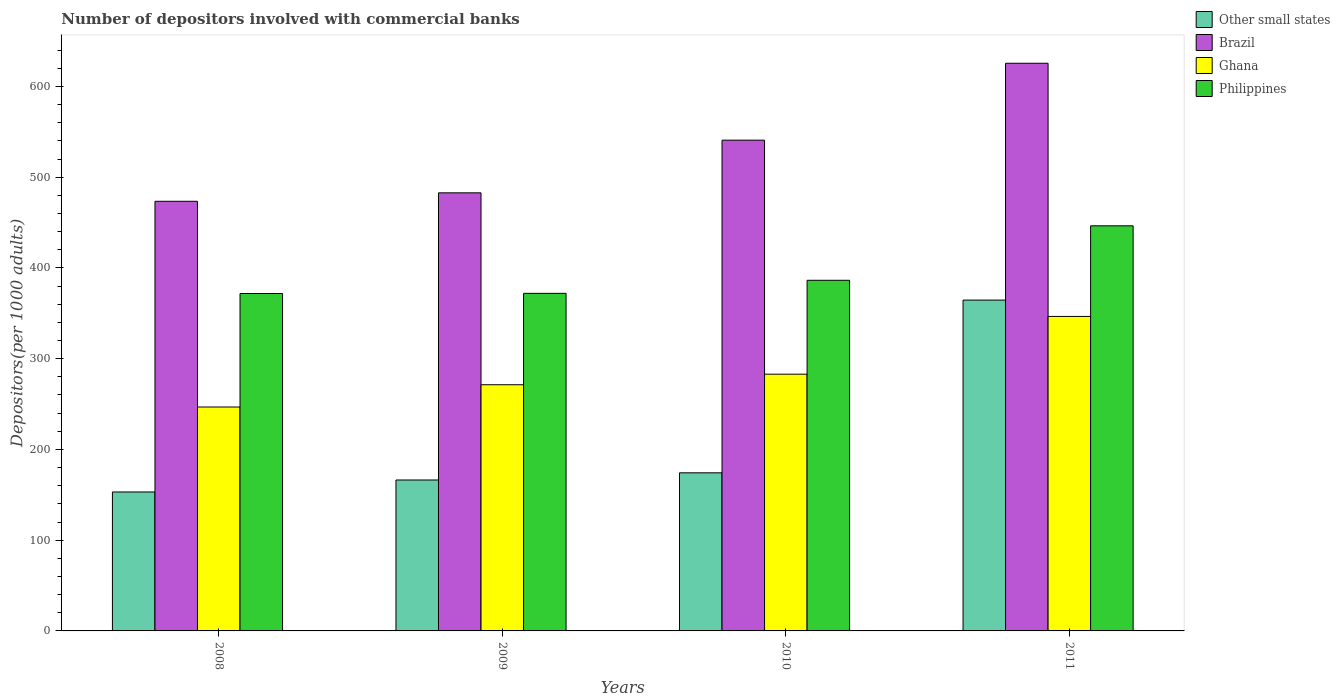How many different coloured bars are there?
Offer a very short reply. 4. How many groups of bars are there?
Your answer should be very brief. 4. Are the number of bars per tick equal to the number of legend labels?
Your answer should be compact. Yes. Are the number of bars on each tick of the X-axis equal?
Keep it short and to the point. Yes. How many bars are there on the 4th tick from the right?
Offer a very short reply. 4. What is the number of depositors involved with commercial banks in Brazil in 2009?
Your answer should be compact. 482.74. Across all years, what is the maximum number of depositors involved with commercial banks in Philippines?
Ensure brevity in your answer.  446.4. Across all years, what is the minimum number of depositors involved with commercial banks in Philippines?
Offer a very short reply. 371.81. In which year was the number of depositors involved with commercial banks in Ghana minimum?
Provide a short and direct response. 2008. What is the total number of depositors involved with commercial banks in Brazil in the graph?
Provide a short and direct response. 2122.49. What is the difference between the number of depositors involved with commercial banks in Ghana in 2008 and that in 2010?
Offer a very short reply. -36.17. What is the difference between the number of depositors involved with commercial banks in Other small states in 2010 and the number of depositors involved with commercial banks in Philippines in 2009?
Make the answer very short. -197.77. What is the average number of depositors involved with commercial banks in Ghana per year?
Your response must be concise. 286.87. In the year 2008, what is the difference between the number of depositors involved with commercial banks in Brazil and number of depositors involved with commercial banks in Ghana?
Offer a very short reply. 226.68. In how many years, is the number of depositors involved with commercial banks in Brazil greater than 100?
Your response must be concise. 4. What is the ratio of the number of depositors involved with commercial banks in Ghana in 2009 to that in 2011?
Offer a very short reply. 0.78. Is the difference between the number of depositors involved with commercial banks in Brazil in 2008 and 2009 greater than the difference between the number of depositors involved with commercial banks in Ghana in 2008 and 2009?
Offer a terse response. Yes. What is the difference between the highest and the second highest number of depositors involved with commercial banks in Other small states?
Offer a terse response. 190.35. What is the difference between the highest and the lowest number of depositors involved with commercial banks in Philippines?
Provide a short and direct response. 74.59. Is it the case that in every year, the sum of the number of depositors involved with commercial banks in Other small states and number of depositors involved with commercial banks in Ghana is greater than the sum of number of depositors involved with commercial banks in Philippines and number of depositors involved with commercial banks in Brazil?
Provide a succinct answer. No. What does the 4th bar from the right in 2009 represents?
Make the answer very short. Other small states. How many bars are there?
Your answer should be compact. 16. Are all the bars in the graph horizontal?
Make the answer very short. No. How many years are there in the graph?
Provide a short and direct response. 4. What is the difference between two consecutive major ticks on the Y-axis?
Your answer should be very brief. 100. Does the graph contain any zero values?
Offer a terse response. No. How many legend labels are there?
Your answer should be compact. 4. How are the legend labels stacked?
Offer a terse response. Vertical. What is the title of the graph?
Offer a terse response. Number of depositors involved with commercial banks. What is the label or title of the X-axis?
Offer a terse response. Years. What is the label or title of the Y-axis?
Offer a terse response. Depositors(per 1000 adults). What is the Depositors(per 1000 adults) of Other small states in 2008?
Keep it short and to the point. 153.11. What is the Depositors(per 1000 adults) of Brazil in 2008?
Make the answer very short. 473.42. What is the Depositors(per 1000 adults) in Ghana in 2008?
Make the answer very short. 246.75. What is the Depositors(per 1000 adults) in Philippines in 2008?
Provide a short and direct response. 371.81. What is the Depositors(per 1000 adults) of Other small states in 2009?
Your answer should be very brief. 166.31. What is the Depositors(per 1000 adults) of Brazil in 2009?
Give a very brief answer. 482.74. What is the Depositors(per 1000 adults) in Ghana in 2009?
Offer a terse response. 271.28. What is the Depositors(per 1000 adults) of Philippines in 2009?
Provide a short and direct response. 371.98. What is the Depositors(per 1000 adults) of Other small states in 2010?
Provide a short and direct response. 174.21. What is the Depositors(per 1000 adults) of Brazil in 2010?
Provide a short and direct response. 540.79. What is the Depositors(per 1000 adults) in Ghana in 2010?
Your answer should be very brief. 282.91. What is the Depositors(per 1000 adults) of Philippines in 2010?
Your answer should be compact. 386.38. What is the Depositors(per 1000 adults) of Other small states in 2011?
Your answer should be compact. 364.57. What is the Depositors(per 1000 adults) in Brazil in 2011?
Ensure brevity in your answer.  625.53. What is the Depositors(per 1000 adults) of Ghana in 2011?
Ensure brevity in your answer.  346.55. What is the Depositors(per 1000 adults) of Philippines in 2011?
Offer a very short reply. 446.4. Across all years, what is the maximum Depositors(per 1000 adults) in Other small states?
Give a very brief answer. 364.57. Across all years, what is the maximum Depositors(per 1000 adults) of Brazil?
Provide a succinct answer. 625.53. Across all years, what is the maximum Depositors(per 1000 adults) of Ghana?
Your response must be concise. 346.55. Across all years, what is the maximum Depositors(per 1000 adults) of Philippines?
Provide a succinct answer. 446.4. Across all years, what is the minimum Depositors(per 1000 adults) of Other small states?
Make the answer very short. 153.11. Across all years, what is the minimum Depositors(per 1000 adults) of Brazil?
Keep it short and to the point. 473.42. Across all years, what is the minimum Depositors(per 1000 adults) of Ghana?
Ensure brevity in your answer.  246.75. Across all years, what is the minimum Depositors(per 1000 adults) of Philippines?
Ensure brevity in your answer.  371.81. What is the total Depositors(per 1000 adults) of Other small states in the graph?
Provide a succinct answer. 858.19. What is the total Depositors(per 1000 adults) of Brazil in the graph?
Give a very brief answer. 2122.49. What is the total Depositors(per 1000 adults) of Ghana in the graph?
Make the answer very short. 1147.49. What is the total Depositors(per 1000 adults) in Philippines in the graph?
Offer a terse response. 1576.57. What is the difference between the Depositors(per 1000 adults) in Other small states in 2008 and that in 2009?
Give a very brief answer. -13.2. What is the difference between the Depositors(per 1000 adults) in Brazil in 2008 and that in 2009?
Keep it short and to the point. -9.32. What is the difference between the Depositors(per 1000 adults) in Ghana in 2008 and that in 2009?
Give a very brief answer. -24.54. What is the difference between the Depositors(per 1000 adults) in Philippines in 2008 and that in 2009?
Provide a short and direct response. -0.17. What is the difference between the Depositors(per 1000 adults) in Other small states in 2008 and that in 2010?
Provide a short and direct response. -21.11. What is the difference between the Depositors(per 1000 adults) of Brazil in 2008 and that in 2010?
Ensure brevity in your answer.  -67.37. What is the difference between the Depositors(per 1000 adults) in Ghana in 2008 and that in 2010?
Make the answer very short. -36.17. What is the difference between the Depositors(per 1000 adults) of Philippines in 2008 and that in 2010?
Make the answer very short. -14.57. What is the difference between the Depositors(per 1000 adults) of Other small states in 2008 and that in 2011?
Provide a short and direct response. -211.46. What is the difference between the Depositors(per 1000 adults) of Brazil in 2008 and that in 2011?
Your response must be concise. -152.11. What is the difference between the Depositors(per 1000 adults) of Ghana in 2008 and that in 2011?
Your answer should be very brief. -99.8. What is the difference between the Depositors(per 1000 adults) of Philippines in 2008 and that in 2011?
Your answer should be very brief. -74.59. What is the difference between the Depositors(per 1000 adults) of Other small states in 2009 and that in 2010?
Provide a short and direct response. -7.91. What is the difference between the Depositors(per 1000 adults) in Brazil in 2009 and that in 2010?
Provide a short and direct response. -58.05. What is the difference between the Depositors(per 1000 adults) of Ghana in 2009 and that in 2010?
Give a very brief answer. -11.63. What is the difference between the Depositors(per 1000 adults) in Philippines in 2009 and that in 2010?
Give a very brief answer. -14.4. What is the difference between the Depositors(per 1000 adults) in Other small states in 2009 and that in 2011?
Provide a short and direct response. -198.26. What is the difference between the Depositors(per 1000 adults) in Brazil in 2009 and that in 2011?
Give a very brief answer. -142.79. What is the difference between the Depositors(per 1000 adults) of Ghana in 2009 and that in 2011?
Your answer should be very brief. -75.26. What is the difference between the Depositors(per 1000 adults) in Philippines in 2009 and that in 2011?
Ensure brevity in your answer.  -74.42. What is the difference between the Depositors(per 1000 adults) in Other small states in 2010 and that in 2011?
Give a very brief answer. -190.35. What is the difference between the Depositors(per 1000 adults) of Brazil in 2010 and that in 2011?
Your answer should be very brief. -84.74. What is the difference between the Depositors(per 1000 adults) in Ghana in 2010 and that in 2011?
Ensure brevity in your answer.  -63.63. What is the difference between the Depositors(per 1000 adults) of Philippines in 2010 and that in 2011?
Provide a succinct answer. -60.02. What is the difference between the Depositors(per 1000 adults) in Other small states in 2008 and the Depositors(per 1000 adults) in Brazil in 2009?
Provide a short and direct response. -329.63. What is the difference between the Depositors(per 1000 adults) of Other small states in 2008 and the Depositors(per 1000 adults) of Ghana in 2009?
Ensure brevity in your answer.  -118.18. What is the difference between the Depositors(per 1000 adults) of Other small states in 2008 and the Depositors(per 1000 adults) of Philippines in 2009?
Your answer should be very brief. -218.87. What is the difference between the Depositors(per 1000 adults) in Brazil in 2008 and the Depositors(per 1000 adults) in Ghana in 2009?
Your response must be concise. 202.14. What is the difference between the Depositors(per 1000 adults) in Brazil in 2008 and the Depositors(per 1000 adults) in Philippines in 2009?
Your answer should be very brief. 101.44. What is the difference between the Depositors(per 1000 adults) of Ghana in 2008 and the Depositors(per 1000 adults) of Philippines in 2009?
Your response must be concise. -125.23. What is the difference between the Depositors(per 1000 adults) of Other small states in 2008 and the Depositors(per 1000 adults) of Brazil in 2010?
Your answer should be very brief. -387.69. What is the difference between the Depositors(per 1000 adults) in Other small states in 2008 and the Depositors(per 1000 adults) in Ghana in 2010?
Ensure brevity in your answer.  -129.81. What is the difference between the Depositors(per 1000 adults) in Other small states in 2008 and the Depositors(per 1000 adults) in Philippines in 2010?
Provide a short and direct response. -233.28. What is the difference between the Depositors(per 1000 adults) of Brazil in 2008 and the Depositors(per 1000 adults) of Ghana in 2010?
Your answer should be compact. 190.51. What is the difference between the Depositors(per 1000 adults) in Brazil in 2008 and the Depositors(per 1000 adults) in Philippines in 2010?
Your answer should be compact. 87.04. What is the difference between the Depositors(per 1000 adults) in Ghana in 2008 and the Depositors(per 1000 adults) in Philippines in 2010?
Provide a succinct answer. -139.64. What is the difference between the Depositors(per 1000 adults) of Other small states in 2008 and the Depositors(per 1000 adults) of Brazil in 2011?
Your response must be concise. -472.42. What is the difference between the Depositors(per 1000 adults) of Other small states in 2008 and the Depositors(per 1000 adults) of Ghana in 2011?
Ensure brevity in your answer.  -193.44. What is the difference between the Depositors(per 1000 adults) in Other small states in 2008 and the Depositors(per 1000 adults) in Philippines in 2011?
Ensure brevity in your answer.  -293.29. What is the difference between the Depositors(per 1000 adults) in Brazil in 2008 and the Depositors(per 1000 adults) in Ghana in 2011?
Provide a short and direct response. 126.88. What is the difference between the Depositors(per 1000 adults) in Brazil in 2008 and the Depositors(per 1000 adults) in Philippines in 2011?
Give a very brief answer. 27.02. What is the difference between the Depositors(per 1000 adults) of Ghana in 2008 and the Depositors(per 1000 adults) of Philippines in 2011?
Offer a terse response. -199.65. What is the difference between the Depositors(per 1000 adults) in Other small states in 2009 and the Depositors(per 1000 adults) in Brazil in 2010?
Your answer should be compact. -374.49. What is the difference between the Depositors(per 1000 adults) of Other small states in 2009 and the Depositors(per 1000 adults) of Ghana in 2010?
Ensure brevity in your answer.  -116.61. What is the difference between the Depositors(per 1000 adults) in Other small states in 2009 and the Depositors(per 1000 adults) in Philippines in 2010?
Give a very brief answer. -220.08. What is the difference between the Depositors(per 1000 adults) in Brazil in 2009 and the Depositors(per 1000 adults) in Ghana in 2010?
Ensure brevity in your answer.  199.83. What is the difference between the Depositors(per 1000 adults) of Brazil in 2009 and the Depositors(per 1000 adults) of Philippines in 2010?
Make the answer very short. 96.36. What is the difference between the Depositors(per 1000 adults) of Ghana in 2009 and the Depositors(per 1000 adults) of Philippines in 2010?
Ensure brevity in your answer.  -115.1. What is the difference between the Depositors(per 1000 adults) of Other small states in 2009 and the Depositors(per 1000 adults) of Brazil in 2011?
Your response must be concise. -459.22. What is the difference between the Depositors(per 1000 adults) of Other small states in 2009 and the Depositors(per 1000 adults) of Ghana in 2011?
Provide a short and direct response. -180.24. What is the difference between the Depositors(per 1000 adults) of Other small states in 2009 and the Depositors(per 1000 adults) of Philippines in 2011?
Make the answer very short. -280.09. What is the difference between the Depositors(per 1000 adults) of Brazil in 2009 and the Depositors(per 1000 adults) of Ghana in 2011?
Your answer should be very brief. 136.19. What is the difference between the Depositors(per 1000 adults) of Brazil in 2009 and the Depositors(per 1000 adults) of Philippines in 2011?
Your response must be concise. 36.34. What is the difference between the Depositors(per 1000 adults) in Ghana in 2009 and the Depositors(per 1000 adults) in Philippines in 2011?
Offer a very short reply. -175.12. What is the difference between the Depositors(per 1000 adults) of Other small states in 2010 and the Depositors(per 1000 adults) of Brazil in 2011?
Give a very brief answer. -451.32. What is the difference between the Depositors(per 1000 adults) in Other small states in 2010 and the Depositors(per 1000 adults) in Ghana in 2011?
Offer a terse response. -172.33. What is the difference between the Depositors(per 1000 adults) of Other small states in 2010 and the Depositors(per 1000 adults) of Philippines in 2011?
Provide a short and direct response. -272.19. What is the difference between the Depositors(per 1000 adults) in Brazil in 2010 and the Depositors(per 1000 adults) in Ghana in 2011?
Make the answer very short. 194.25. What is the difference between the Depositors(per 1000 adults) in Brazil in 2010 and the Depositors(per 1000 adults) in Philippines in 2011?
Provide a succinct answer. 94.39. What is the difference between the Depositors(per 1000 adults) in Ghana in 2010 and the Depositors(per 1000 adults) in Philippines in 2011?
Provide a succinct answer. -163.49. What is the average Depositors(per 1000 adults) of Other small states per year?
Keep it short and to the point. 214.55. What is the average Depositors(per 1000 adults) in Brazil per year?
Provide a succinct answer. 530.62. What is the average Depositors(per 1000 adults) of Ghana per year?
Provide a short and direct response. 286.87. What is the average Depositors(per 1000 adults) of Philippines per year?
Keep it short and to the point. 394.14. In the year 2008, what is the difference between the Depositors(per 1000 adults) of Other small states and Depositors(per 1000 adults) of Brazil?
Your answer should be compact. -320.32. In the year 2008, what is the difference between the Depositors(per 1000 adults) in Other small states and Depositors(per 1000 adults) in Ghana?
Ensure brevity in your answer.  -93.64. In the year 2008, what is the difference between the Depositors(per 1000 adults) in Other small states and Depositors(per 1000 adults) in Philippines?
Make the answer very short. -218.7. In the year 2008, what is the difference between the Depositors(per 1000 adults) in Brazil and Depositors(per 1000 adults) in Ghana?
Your answer should be compact. 226.68. In the year 2008, what is the difference between the Depositors(per 1000 adults) of Brazil and Depositors(per 1000 adults) of Philippines?
Make the answer very short. 101.61. In the year 2008, what is the difference between the Depositors(per 1000 adults) in Ghana and Depositors(per 1000 adults) in Philippines?
Provide a succinct answer. -125.07. In the year 2009, what is the difference between the Depositors(per 1000 adults) of Other small states and Depositors(per 1000 adults) of Brazil?
Your answer should be compact. -316.43. In the year 2009, what is the difference between the Depositors(per 1000 adults) in Other small states and Depositors(per 1000 adults) in Ghana?
Your answer should be very brief. -104.98. In the year 2009, what is the difference between the Depositors(per 1000 adults) in Other small states and Depositors(per 1000 adults) in Philippines?
Provide a succinct answer. -205.67. In the year 2009, what is the difference between the Depositors(per 1000 adults) in Brazil and Depositors(per 1000 adults) in Ghana?
Give a very brief answer. 211.46. In the year 2009, what is the difference between the Depositors(per 1000 adults) of Brazil and Depositors(per 1000 adults) of Philippines?
Keep it short and to the point. 110.76. In the year 2009, what is the difference between the Depositors(per 1000 adults) in Ghana and Depositors(per 1000 adults) in Philippines?
Provide a short and direct response. -100.7. In the year 2010, what is the difference between the Depositors(per 1000 adults) of Other small states and Depositors(per 1000 adults) of Brazil?
Make the answer very short. -366.58. In the year 2010, what is the difference between the Depositors(per 1000 adults) in Other small states and Depositors(per 1000 adults) in Ghana?
Keep it short and to the point. -108.7. In the year 2010, what is the difference between the Depositors(per 1000 adults) in Other small states and Depositors(per 1000 adults) in Philippines?
Provide a short and direct response. -212.17. In the year 2010, what is the difference between the Depositors(per 1000 adults) in Brazil and Depositors(per 1000 adults) in Ghana?
Your response must be concise. 257.88. In the year 2010, what is the difference between the Depositors(per 1000 adults) in Brazil and Depositors(per 1000 adults) in Philippines?
Provide a succinct answer. 154.41. In the year 2010, what is the difference between the Depositors(per 1000 adults) of Ghana and Depositors(per 1000 adults) of Philippines?
Provide a succinct answer. -103.47. In the year 2011, what is the difference between the Depositors(per 1000 adults) in Other small states and Depositors(per 1000 adults) in Brazil?
Offer a terse response. -260.96. In the year 2011, what is the difference between the Depositors(per 1000 adults) in Other small states and Depositors(per 1000 adults) in Ghana?
Your response must be concise. 18.02. In the year 2011, what is the difference between the Depositors(per 1000 adults) in Other small states and Depositors(per 1000 adults) in Philippines?
Your answer should be very brief. -81.83. In the year 2011, what is the difference between the Depositors(per 1000 adults) of Brazil and Depositors(per 1000 adults) of Ghana?
Offer a very short reply. 278.99. In the year 2011, what is the difference between the Depositors(per 1000 adults) in Brazil and Depositors(per 1000 adults) in Philippines?
Your answer should be compact. 179.13. In the year 2011, what is the difference between the Depositors(per 1000 adults) in Ghana and Depositors(per 1000 adults) in Philippines?
Ensure brevity in your answer.  -99.85. What is the ratio of the Depositors(per 1000 adults) in Other small states in 2008 to that in 2009?
Keep it short and to the point. 0.92. What is the ratio of the Depositors(per 1000 adults) of Brazil in 2008 to that in 2009?
Offer a terse response. 0.98. What is the ratio of the Depositors(per 1000 adults) of Ghana in 2008 to that in 2009?
Keep it short and to the point. 0.91. What is the ratio of the Depositors(per 1000 adults) of Other small states in 2008 to that in 2010?
Ensure brevity in your answer.  0.88. What is the ratio of the Depositors(per 1000 adults) in Brazil in 2008 to that in 2010?
Your answer should be compact. 0.88. What is the ratio of the Depositors(per 1000 adults) in Ghana in 2008 to that in 2010?
Keep it short and to the point. 0.87. What is the ratio of the Depositors(per 1000 adults) in Philippines in 2008 to that in 2010?
Keep it short and to the point. 0.96. What is the ratio of the Depositors(per 1000 adults) of Other small states in 2008 to that in 2011?
Provide a succinct answer. 0.42. What is the ratio of the Depositors(per 1000 adults) in Brazil in 2008 to that in 2011?
Provide a short and direct response. 0.76. What is the ratio of the Depositors(per 1000 adults) in Ghana in 2008 to that in 2011?
Keep it short and to the point. 0.71. What is the ratio of the Depositors(per 1000 adults) in Philippines in 2008 to that in 2011?
Keep it short and to the point. 0.83. What is the ratio of the Depositors(per 1000 adults) of Other small states in 2009 to that in 2010?
Your answer should be compact. 0.95. What is the ratio of the Depositors(per 1000 adults) of Brazil in 2009 to that in 2010?
Offer a very short reply. 0.89. What is the ratio of the Depositors(per 1000 adults) of Ghana in 2009 to that in 2010?
Offer a very short reply. 0.96. What is the ratio of the Depositors(per 1000 adults) in Philippines in 2009 to that in 2010?
Ensure brevity in your answer.  0.96. What is the ratio of the Depositors(per 1000 adults) of Other small states in 2009 to that in 2011?
Provide a succinct answer. 0.46. What is the ratio of the Depositors(per 1000 adults) in Brazil in 2009 to that in 2011?
Offer a very short reply. 0.77. What is the ratio of the Depositors(per 1000 adults) of Ghana in 2009 to that in 2011?
Keep it short and to the point. 0.78. What is the ratio of the Depositors(per 1000 adults) of Philippines in 2009 to that in 2011?
Keep it short and to the point. 0.83. What is the ratio of the Depositors(per 1000 adults) of Other small states in 2010 to that in 2011?
Keep it short and to the point. 0.48. What is the ratio of the Depositors(per 1000 adults) in Brazil in 2010 to that in 2011?
Your answer should be compact. 0.86. What is the ratio of the Depositors(per 1000 adults) of Ghana in 2010 to that in 2011?
Your answer should be compact. 0.82. What is the ratio of the Depositors(per 1000 adults) in Philippines in 2010 to that in 2011?
Your answer should be compact. 0.87. What is the difference between the highest and the second highest Depositors(per 1000 adults) of Other small states?
Offer a very short reply. 190.35. What is the difference between the highest and the second highest Depositors(per 1000 adults) in Brazil?
Give a very brief answer. 84.74. What is the difference between the highest and the second highest Depositors(per 1000 adults) in Ghana?
Provide a succinct answer. 63.63. What is the difference between the highest and the second highest Depositors(per 1000 adults) in Philippines?
Ensure brevity in your answer.  60.02. What is the difference between the highest and the lowest Depositors(per 1000 adults) in Other small states?
Offer a very short reply. 211.46. What is the difference between the highest and the lowest Depositors(per 1000 adults) of Brazil?
Make the answer very short. 152.11. What is the difference between the highest and the lowest Depositors(per 1000 adults) in Ghana?
Your answer should be compact. 99.8. What is the difference between the highest and the lowest Depositors(per 1000 adults) of Philippines?
Provide a succinct answer. 74.59. 